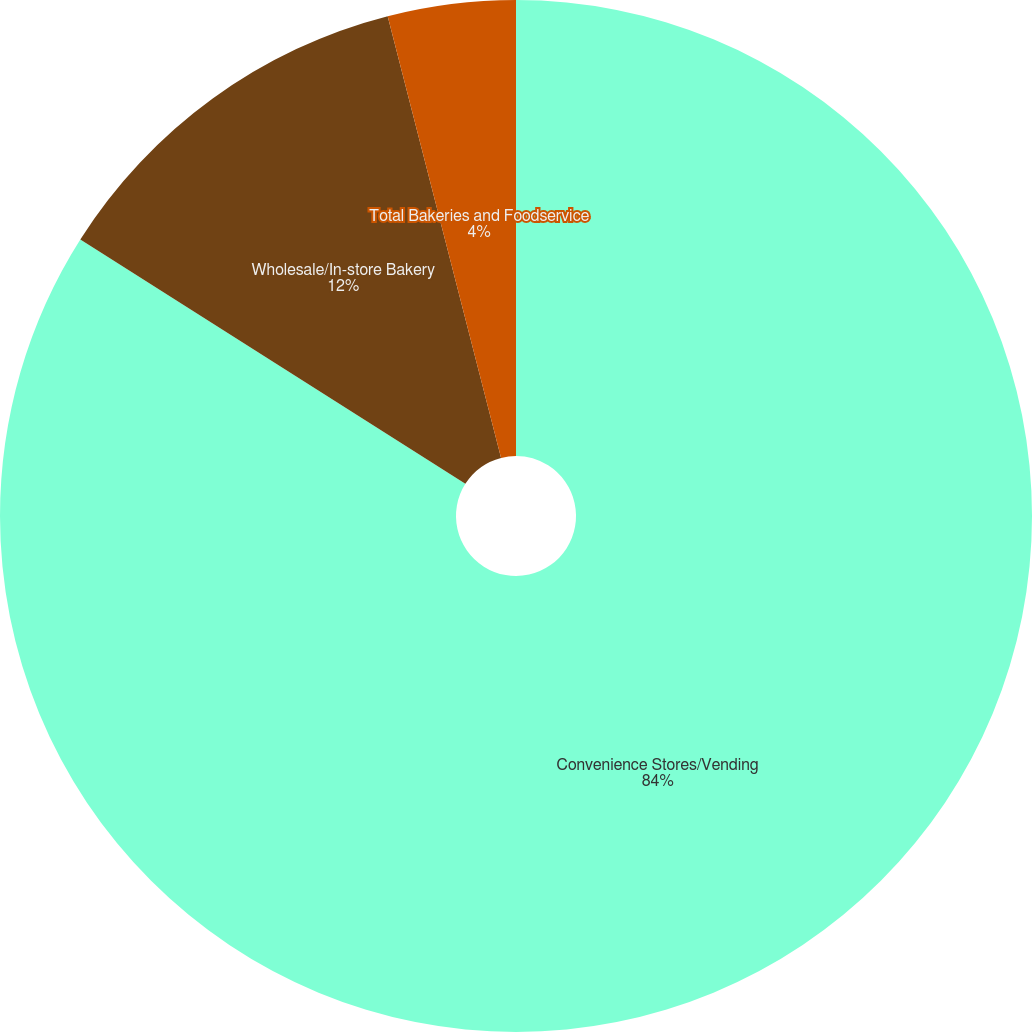Convert chart. <chart><loc_0><loc_0><loc_500><loc_500><pie_chart><fcel>Convenience Stores/Vending<fcel>Wholesale/In-store Bakery<fcel>Total Bakeries and Foodservice<nl><fcel>84.0%<fcel>12.0%<fcel>4.0%<nl></chart> 